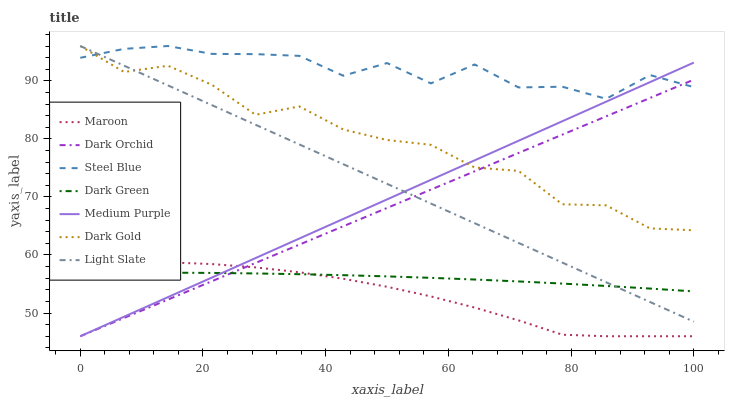Does Light Slate have the minimum area under the curve?
Answer yes or no. No. Does Light Slate have the maximum area under the curve?
Answer yes or no. No. Is Light Slate the smoothest?
Answer yes or no. No. Is Light Slate the roughest?
Answer yes or no. No. Does Light Slate have the lowest value?
Answer yes or no. No. Does Dark Orchid have the highest value?
Answer yes or no. No. Is Maroon less than Steel Blue?
Answer yes or no. Yes. Is Dark Gold greater than Maroon?
Answer yes or no. Yes. Does Maroon intersect Steel Blue?
Answer yes or no. No. 